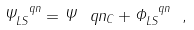Convert formula to latex. <formula><loc_0><loc_0><loc_500><loc_500>\Psi ^ { \ q n } _ { L S } = \Psi ^ { \ } q n _ { C } + \Phi ^ { \ q n } _ { L S } \ ,</formula> 